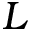Convert formula to latex. <formula><loc_0><loc_0><loc_500><loc_500>L</formula> 